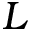Convert formula to latex. <formula><loc_0><loc_0><loc_500><loc_500>L</formula> 